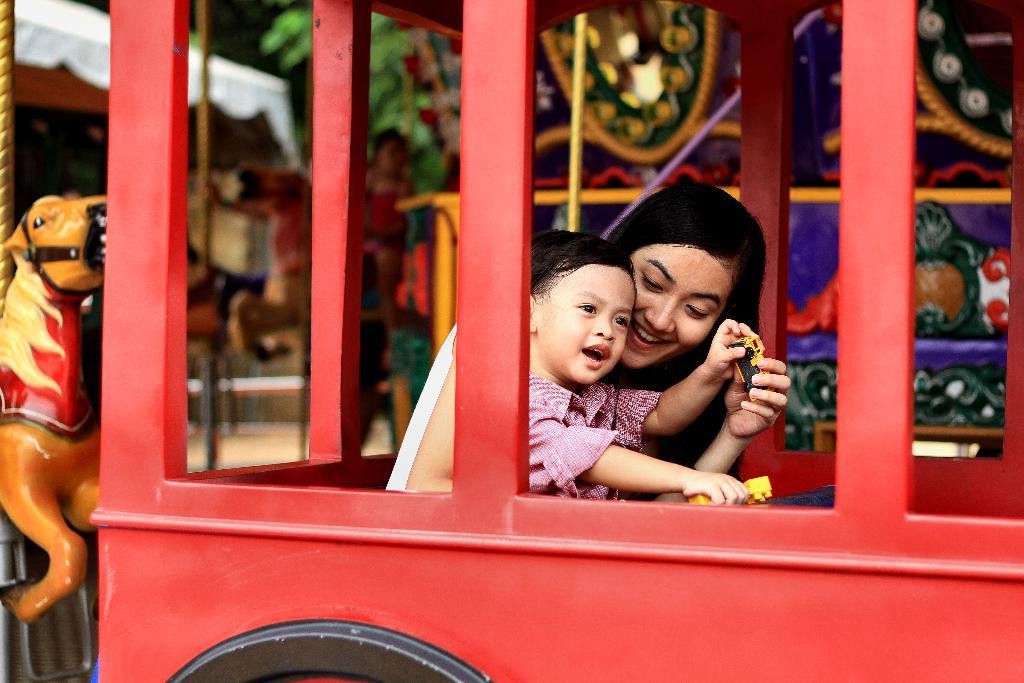How many people are in the vehicle in the image? There are two persons sitting in the vehicle. What else can be seen in the image besides the vehicle? There is a person in the background of the image and a horse carousel ride. What type of liquid is being poured on the floor in the image? There is no liquid being poured on the floor in the image. How comfortable is the carousel ride for the person in the background? The comfort level of the carousel ride for the person in the background cannot be determined from the image. 